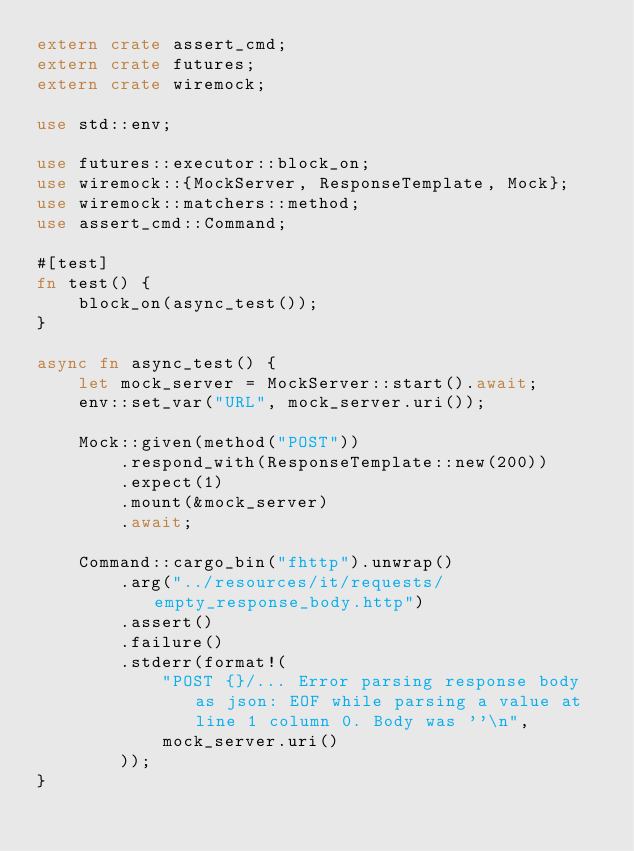<code> <loc_0><loc_0><loc_500><loc_500><_Rust_>extern crate assert_cmd;
extern crate futures;
extern crate wiremock;

use std::env;

use futures::executor::block_on;
use wiremock::{MockServer, ResponseTemplate, Mock};
use wiremock::matchers::method;
use assert_cmd::Command;

#[test]
fn test() {
    block_on(async_test());
}

async fn async_test() {
    let mock_server = MockServer::start().await;
    env::set_var("URL", mock_server.uri());

    Mock::given(method("POST"))
        .respond_with(ResponseTemplate::new(200))
        .expect(1)
        .mount(&mock_server)
        .await;

    Command::cargo_bin("fhttp").unwrap()
        .arg("../resources/it/requests/empty_response_body.http")
        .assert()
        .failure()
        .stderr(format!(
            "POST {}/... Error parsing response body as json: EOF while parsing a value at line 1 column 0. Body was ''\n",
            mock_server.uri()
        ));
}
</code> 